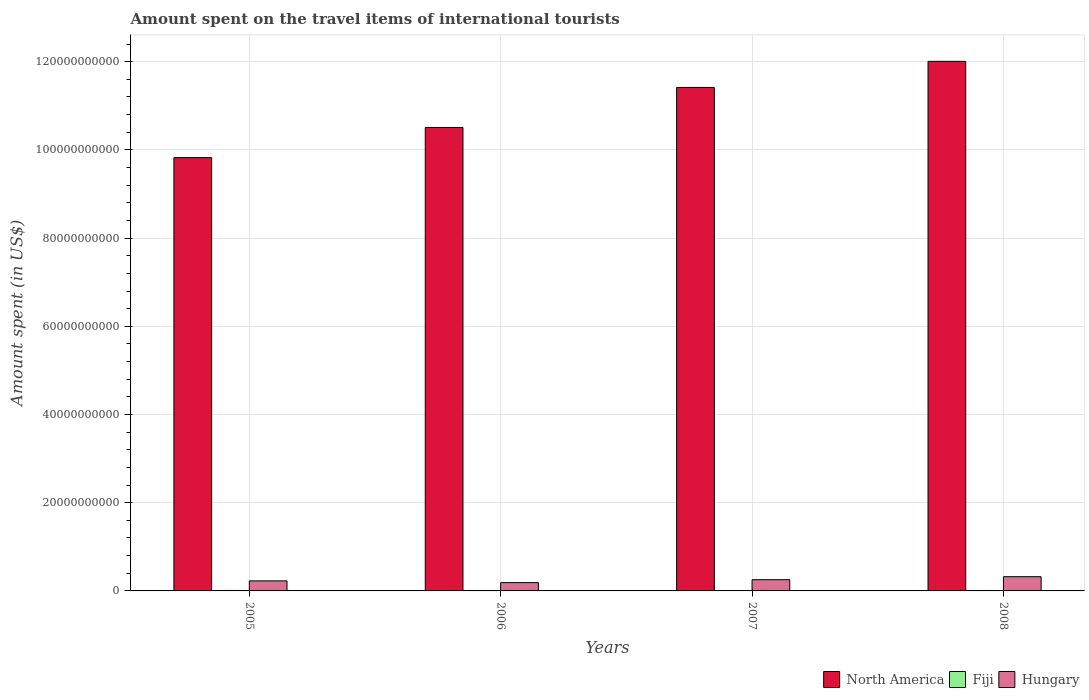How many different coloured bars are there?
Your answer should be compact. 3. How many bars are there on the 4th tick from the left?
Keep it short and to the point. 3. In how many cases, is the number of bars for a given year not equal to the number of legend labels?
Your answer should be very brief. 0. What is the amount spent on the travel items of international tourists in North America in 2007?
Provide a short and direct response. 1.14e+11. Across all years, what is the maximum amount spent on the travel items of international tourists in Fiji?
Offer a very short reply. 1.06e+08. Across all years, what is the minimum amount spent on the travel items of international tourists in Hungary?
Provide a succinct answer. 1.88e+09. In which year was the amount spent on the travel items of international tourists in Hungary minimum?
Give a very brief answer. 2006. What is the total amount spent on the travel items of international tourists in Hungary in the graph?
Make the answer very short. 9.93e+09. What is the difference between the amount spent on the travel items of international tourists in North America in 2006 and that in 2008?
Your answer should be very brief. -1.50e+1. What is the difference between the amount spent on the travel items of international tourists in Fiji in 2008 and the amount spent on the travel items of international tourists in North America in 2005?
Your response must be concise. -9.82e+1. What is the average amount spent on the travel items of international tourists in Hungary per year?
Your answer should be very brief. 2.48e+09. In the year 2005, what is the difference between the amount spent on the travel items of international tourists in North America and amount spent on the travel items of international tourists in Fiji?
Ensure brevity in your answer.  9.81e+1. What is the ratio of the amount spent on the travel items of international tourists in Hungary in 2007 to that in 2008?
Your answer should be very brief. 0.79. Is the amount spent on the travel items of international tourists in Fiji in 2005 less than that in 2007?
Offer a terse response. No. What is the difference between the highest and the lowest amount spent on the travel items of international tourists in North America?
Provide a short and direct response. 2.18e+1. Is the sum of the amount spent on the travel items of international tourists in Hungary in 2005 and 2008 greater than the maximum amount spent on the travel items of international tourists in Fiji across all years?
Provide a short and direct response. Yes. What does the 1st bar from the left in 2007 represents?
Make the answer very short. North America. Is it the case that in every year, the sum of the amount spent on the travel items of international tourists in Hungary and amount spent on the travel items of international tourists in Fiji is greater than the amount spent on the travel items of international tourists in North America?
Your response must be concise. No. How many bars are there?
Your answer should be very brief. 12. How many years are there in the graph?
Your response must be concise. 4. Are the values on the major ticks of Y-axis written in scientific E-notation?
Ensure brevity in your answer.  No. Does the graph contain grids?
Your answer should be very brief. Yes. How many legend labels are there?
Your answer should be compact. 3. How are the legend labels stacked?
Your response must be concise. Horizontal. What is the title of the graph?
Offer a terse response. Amount spent on the travel items of international tourists. What is the label or title of the X-axis?
Make the answer very short. Years. What is the label or title of the Y-axis?
Make the answer very short. Amount spent (in US$). What is the Amount spent (in US$) of North America in 2005?
Make the answer very short. 9.82e+1. What is the Amount spent (in US$) in Fiji in 2005?
Provide a short and direct response. 1.06e+08. What is the Amount spent (in US$) in Hungary in 2005?
Provide a succinct answer. 2.28e+09. What is the Amount spent (in US$) of North America in 2006?
Offer a very short reply. 1.05e+11. What is the Amount spent (in US$) of Fiji in 2006?
Offer a terse response. 1.01e+08. What is the Amount spent (in US$) of Hungary in 2006?
Provide a short and direct response. 1.88e+09. What is the Amount spent (in US$) of North America in 2007?
Your response must be concise. 1.14e+11. What is the Amount spent (in US$) of Fiji in 2007?
Your answer should be compact. 9.20e+07. What is the Amount spent (in US$) of Hungary in 2007?
Ensure brevity in your answer.  2.55e+09. What is the Amount spent (in US$) of North America in 2008?
Ensure brevity in your answer.  1.20e+11. What is the Amount spent (in US$) of Fiji in 2008?
Keep it short and to the point. 9.60e+07. What is the Amount spent (in US$) in Hungary in 2008?
Give a very brief answer. 3.22e+09. Across all years, what is the maximum Amount spent (in US$) in North America?
Give a very brief answer. 1.20e+11. Across all years, what is the maximum Amount spent (in US$) in Fiji?
Make the answer very short. 1.06e+08. Across all years, what is the maximum Amount spent (in US$) in Hungary?
Provide a short and direct response. 3.22e+09. Across all years, what is the minimum Amount spent (in US$) of North America?
Make the answer very short. 9.82e+1. Across all years, what is the minimum Amount spent (in US$) in Fiji?
Your answer should be very brief. 9.20e+07. Across all years, what is the minimum Amount spent (in US$) of Hungary?
Ensure brevity in your answer.  1.88e+09. What is the total Amount spent (in US$) of North America in the graph?
Provide a succinct answer. 4.38e+11. What is the total Amount spent (in US$) in Fiji in the graph?
Keep it short and to the point. 3.95e+08. What is the total Amount spent (in US$) in Hungary in the graph?
Ensure brevity in your answer.  9.93e+09. What is the difference between the Amount spent (in US$) in North America in 2005 and that in 2006?
Give a very brief answer. -6.84e+09. What is the difference between the Amount spent (in US$) of Hungary in 2005 and that in 2006?
Provide a succinct answer. 3.98e+08. What is the difference between the Amount spent (in US$) in North America in 2005 and that in 2007?
Provide a short and direct response. -1.59e+1. What is the difference between the Amount spent (in US$) of Fiji in 2005 and that in 2007?
Provide a short and direct response. 1.40e+07. What is the difference between the Amount spent (in US$) in Hungary in 2005 and that in 2007?
Offer a terse response. -2.69e+08. What is the difference between the Amount spent (in US$) in North America in 2005 and that in 2008?
Offer a very short reply. -2.18e+1. What is the difference between the Amount spent (in US$) in Hungary in 2005 and that in 2008?
Provide a short and direct response. -9.48e+08. What is the difference between the Amount spent (in US$) in North America in 2006 and that in 2007?
Offer a terse response. -9.08e+09. What is the difference between the Amount spent (in US$) of Fiji in 2006 and that in 2007?
Provide a short and direct response. 9.00e+06. What is the difference between the Amount spent (in US$) in Hungary in 2006 and that in 2007?
Give a very brief answer. -6.67e+08. What is the difference between the Amount spent (in US$) of North America in 2006 and that in 2008?
Provide a succinct answer. -1.50e+1. What is the difference between the Amount spent (in US$) of Hungary in 2006 and that in 2008?
Your answer should be compact. -1.35e+09. What is the difference between the Amount spent (in US$) in North America in 2007 and that in 2008?
Make the answer very short. -5.92e+09. What is the difference between the Amount spent (in US$) in Hungary in 2007 and that in 2008?
Provide a short and direct response. -6.79e+08. What is the difference between the Amount spent (in US$) in North America in 2005 and the Amount spent (in US$) in Fiji in 2006?
Ensure brevity in your answer.  9.81e+1. What is the difference between the Amount spent (in US$) of North America in 2005 and the Amount spent (in US$) of Hungary in 2006?
Offer a very short reply. 9.64e+1. What is the difference between the Amount spent (in US$) of Fiji in 2005 and the Amount spent (in US$) of Hungary in 2006?
Offer a very short reply. -1.77e+09. What is the difference between the Amount spent (in US$) of North America in 2005 and the Amount spent (in US$) of Fiji in 2007?
Ensure brevity in your answer.  9.82e+1. What is the difference between the Amount spent (in US$) in North America in 2005 and the Amount spent (in US$) in Hungary in 2007?
Make the answer very short. 9.57e+1. What is the difference between the Amount spent (in US$) of Fiji in 2005 and the Amount spent (in US$) of Hungary in 2007?
Your answer should be compact. -2.44e+09. What is the difference between the Amount spent (in US$) of North America in 2005 and the Amount spent (in US$) of Fiji in 2008?
Make the answer very short. 9.82e+1. What is the difference between the Amount spent (in US$) in North America in 2005 and the Amount spent (in US$) in Hungary in 2008?
Provide a short and direct response. 9.50e+1. What is the difference between the Amount spent (in US$) of Fiji in 2005 and the Amount spent (in US$) of Hungary in 2008?
Ensure brevity in your answer.  -3.12e+09. What is the difference between the Amount spent (in US$) in North America in 2006 and the Amount spent (in US$) in Fiji in 2007?
Your answer should be very brief. 1.05e+11. What is the difference between the Amount spent (in US$) in North America in 2006 and the Amount spent (in US$) in Hungary in 2007?
Your response must be concise. 1.03e+11. What is the difference between the Amount spent (in US$) of Fiji in 2006 and the Amount spent (in US$) of Hungary in 2007?
Offer a very short reply. -2.44e+09. What is the difference between the Amount spent (in US$) in North America in 2006 and the Amount spent (in US$) in Fiji in 2008?
Your response must be concise. 1.05e+11. What is the difference between the Amount spent (in US$) of North America in 2006 and the Amount spent (in US$) of Hungary in 2008?
Keep it short and to the point. 1.02e+11. What is the difference between the Amount spent (in US$) in Fiji in 2006 and the Amount spent (in US$) in Hungary in 2008?
Ensure brevity in your answer.  -3.12e+09. What is the difference between the Amount spent (in US$) of North America in 2007 and the Amount spent (in US$) of Fiji in 2008?
Keep it short and to the point. 1.14e+11. What is the difference between the Amount spent (in US$) in North America in 2007 and the Amount spent (in US$) in Hungary in 2008?
Keep it short and to the point. 1.11e+11. What is the difference between the Amount spent (in US$) of Fiji in 2007 and the Amount spent (in US$) of Hungary in 2008?
Your answer should be very brief. -3.13e+09. What is the average Amount spent (in US$) of North America per year?
Your answer should be very brief. 1.09e+11. What is the average Amount spent (in US$) in Fiji per year?
Offer a terse response. 9.88e+07. What is the average Amount spent (in US$) in Hungary per year?
Your answer should be compact. 2.48e+09. In the year 2005, what is the difference between the Amount spent (in US$) in North America and Amount spent (in US$) in Fiji?
Offer a very short reply. 9.81e+1. In the year 2005, what is the difference between the Amount spent (in US$) of North America and Amount spent (in US$) of Hungary?
Give a very brief answer. 9.60e+1. In the year 2005, what is the difference between the Amount spent (in US$) in Fiji and Amount spent (in US$) in Hungary?
Provide a short and direct response. -2.17e+09. In the year 2006, what is the difference between the Amount spent (in US$) of North America and Amount spent (in US$) of Fiji?
Your response must be concise. 1.05e+11. In the year 2006, what is the difference between the Amount spent (in US$) of North America and Amount spent (in US$) of Hungary?
Your response must be concise. 1.03e+11. In the year 2006, what is the difference between the Amount spent (in US$) in Fiji and Amount spent (in US$) in Hungary?
Provide a succinct answer. -1.78e+09. In the year 2007, what is the difference between the Amount spent (in US$) in North America and Amount spent (in US$) in Fiji?
Provide a succinct answer. 1.14e+11. In the year 2007, what is the difference between the Amount spent (in US$) of North America and Amount spent (in US$) of Hungary?
Your answer should be compact. 1.12e+11. In the year 2007, what is the difference between the Amount spent (in US$) in Fiji and Amount spent (in US$) in Hungary?
Your answer should be very brief. -2.45e+09. In the year 2008, what is the difference between the Amount spent (in US$) in North America and Amount spent (in US$) in Fiji?
Your answer should be compact. 1.20e+11. In the year 2008, what is the difference between the Amount spent (in US$) of North America and Amount spent (in US$) of Hungary?
Keep it short and to the point. 1.17e+11. In the year 2008, what is the difference between the Amount spent (in US$) in Fiji and Amount spent (in US$) in Hungary?
Give a very brief answer. -3.13e+09. What is the ratio of the Amount spent (in US$) of North America in 2005 to that in 2006?
Ensure brevity in your answer.  0.93. What is the ratio of the Amount spent (in US$) of Fiji in 2005 to that in 2006?
Your answer should be compact. 1.05. What is the ratio of the Amount spent (in US$) of Hungary in 2005 to that in 2006?
Provide a short and direct response. 1.21. What is the ratio of the Amount spent (in US$) in North America in 2005 to that in 2007?
Ensure brevity in your answer.  0.86. What is the ratio of the Amount spent (in US$) of Fiji in 2005 to that in 2007?
Make the answer very short. 1.15. What is the ratio of the Amount spent (in US$) in Hungary in 2005 to that in 2007?
Offer a terse response. 0.89. What is the ratio of the Amount spent (in US$) in North America in 2005 to that in 2008?
Ensure brevity in your answer.  0.82. What is the ratio of the Amount spent (in US$) in Fiji in 2005 to that in 2008?
Your answer should be very brief. 1.1. What is the ratio of the Amount spent (in US$) in Hungary in 2005 to that in 2008?
Your answer should be compact. 0.71. What is the ratio of the Amount spent (in US$) of North America in 2006 to that in 2007?
Give a very brief answer. 0.92. What is the ratio of the Amount spent (in US$) of Fiji in 2006 to that in 2007?
Give a very brief answer. 1.1. What is the ratio of the Amount spent (in US$) of Hungary in 2006 to that in 2007?
Make the answer very short. 0.74. What is the ratio of the Amount spent (in US$) of North America in 2006 to that in 2008?
Offer a very short reply. 0.88. What is the ratio of the Amount spent (in US$) of Fiji in 2006 to that in 2008?
Your answer should be compact. 1.05. What is the ratio of the Amount spent (in US$) in Hungary in 2006 to that in 2008?
Your answer should be very brief. 0.58. What is the ratio of the Amount spent (in US$) in North America in 2007 to that in 2008?
Make the answer very short. 0.95. What is the ratio of the Amount spent (in US$) in Hungary in 2007 to that in 2008?
Your response must be concise. 0.79. What is the difference between the highest and the second highest Amount spent (in US$) of North America?
Your response must be concise. 5.92e+09. What is the difference between the highest and the second highest Amount spent (in US$) of Fiji?
Your answer should be very brief. 5.00e+06. What is the difference between the highest and the second highest Amount spent (in US$) in Hungary?
Your answer should be compact. 6.79e+08. What is the difference between the highest and the lowest Amount spent (in US$) in North America?
Make the answer very short. 2.18e+1. What is the difference between the highest and the lowest Amount spent (in US$) in Fiji?
Offer a terse response. 1.40e+07. What is the difference between the highest and the lowest Amount spent (in US$) of Hungary?
Keep it short and to the point. 1.35e+09. 